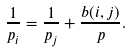Convert formula to latex. <formula><loc_0><loc_0><loc_500><loc_500>\frac { 1 } { p _ { i } } = \frac { 1 } { p _ { j } } + \frac { b ( i , j ) } { p } .</formula> 